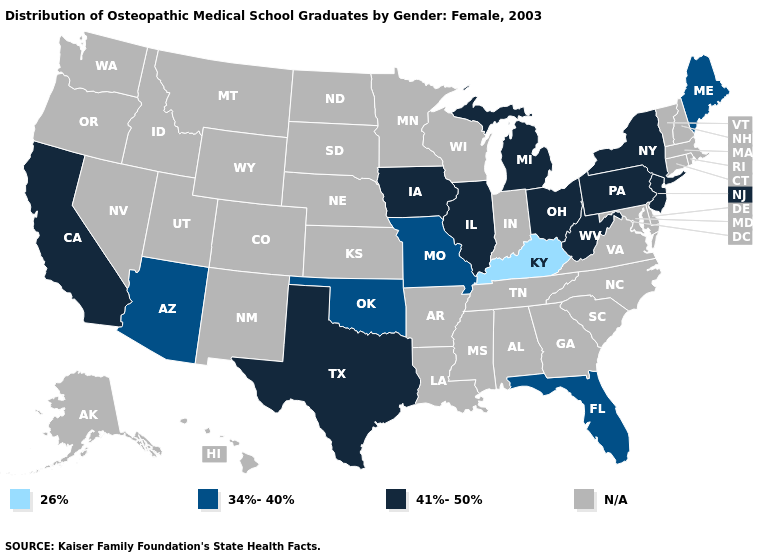Name the states that have a value in the range 34%-40%?
Concise answer only. Arizona, Florida, Maine, Missouri, Oklahoma. What is the value of Nebraska?
Keep it brief. N/A. Does Kentucky have the lowest value in the USA?
Concise answer only. Yes. What is the highest value in the USA?
Give a very brief answer. 41%-50%. What is the lowest value in the USA?
Concise answer only. 26%. How many symbols are there in the legend?
Answer briefly. 4. Name the states that have a value in the range 41%-50%?
Keep it brief. California, Illinois, Iowa, Michigan, New Jersey, New York, Ohio, Pennsylvania, Texas, West Virginia. What is the value of Mississippi?
Be succinct. N/A. What is the highest value in the West ?
Concise answer only. 41%-50%. What is the value of Wyoming?
Write a very short answer. N/A. Does Arizona have the highest value in the West?
Short answer required. No. What is the value of Alaska?
Quick response, please. N/A. 